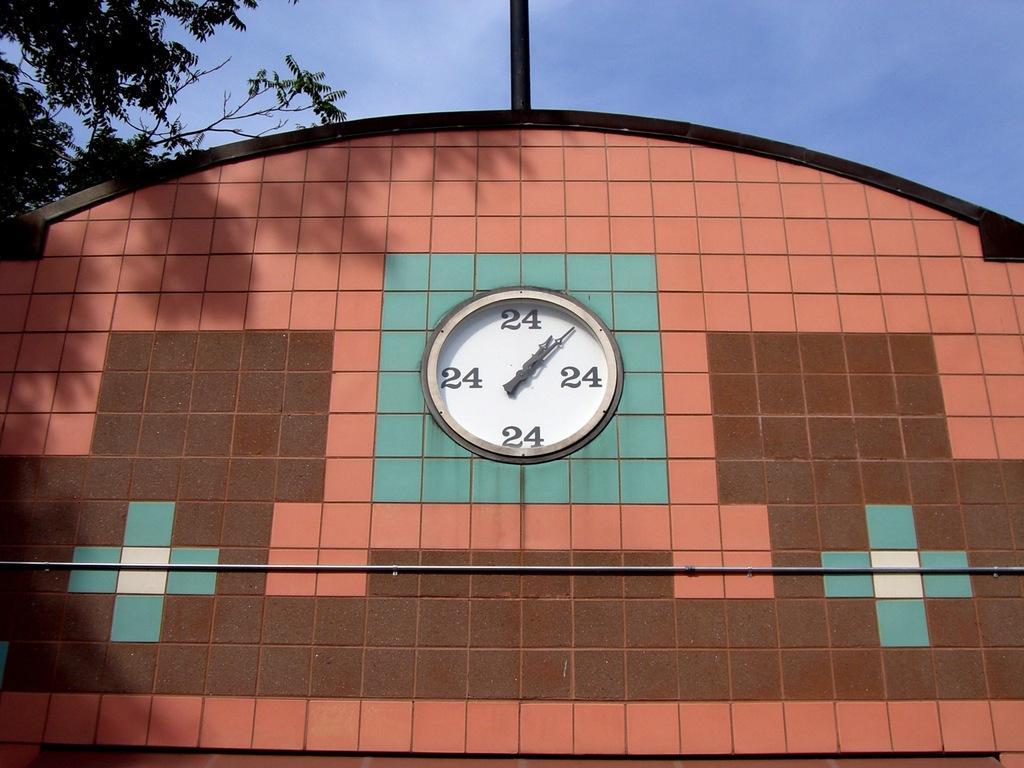Could you give a brief overview of what you see in this image? In this picture I can see there is a building and it has different colors on the wall. There is a clock and it has a minute and hour hand and there are numbers on the dial. In the backdrop there is a pole and the sky is clear. 